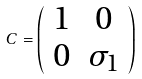<formula> <loc_0><loc_0><loc_500><loc_500>C = \left ( \begin{array} { c c } 1 & 0 \\ 0 & \sigma _ { 1 } \end{array} \right )</formula> 